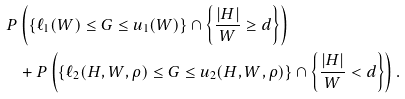<formula> <loc_0><loc_0><loc_500><loc_500>P & \left ( \{ \ell _ { 1 } ( W ) \leq G \leq u _ { 1 } ( W ) \} \cap \left \{ \frac { | H | } { W } \geq d \right \} \right ) \\ & + P \left ( \{ \ell _ { 2 } ( H , W , \rho ) \leq G \leq u _ { 2 } ( H , W , \rho ) \} \cap \left \{ \frac { | H | } { W } < d \right \} \right ) .</formula> 